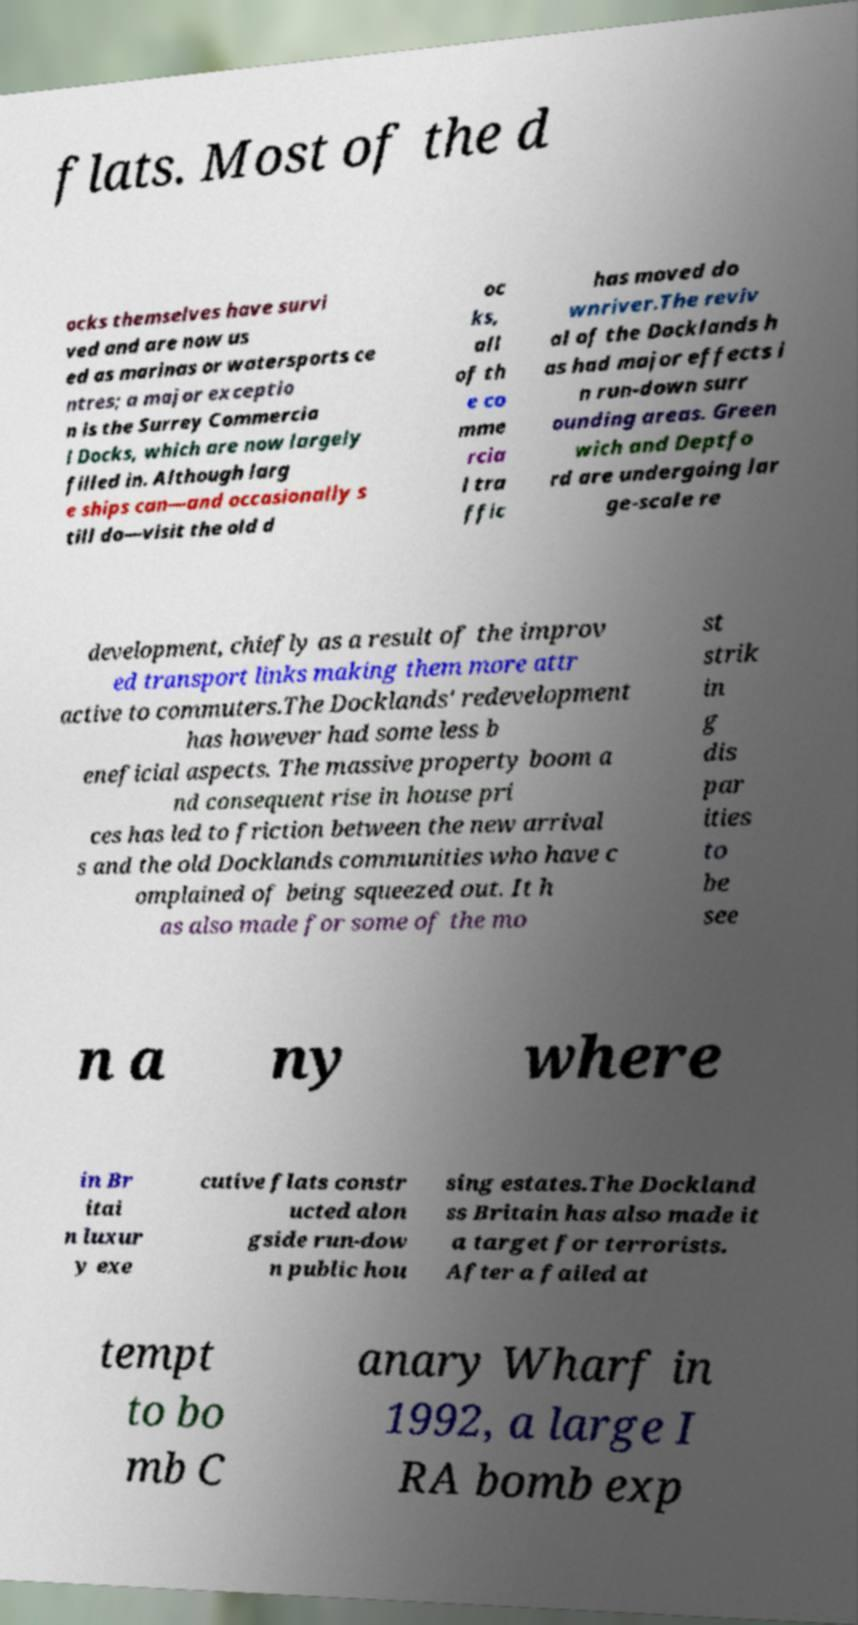For documentation purposes, I need the text within this image transcribed. Could you provide that? flats. Most of the d ocks themselves have survi ved and are now us ed as marinas or watersports ce ntres; a major exceptio n is the Surrey Commercia l Docks, which are now largely filled in. Although larg e ships can—and occasionally s till do—visit the old d oc ks, all of th e co mme rcia l tra ffic has moved do wnriver.The reviv al of the Docklands h as had major effects i n run-down surr ounding areas. Green wich and Deptfo rd are undergoing lar ge-scale re development, chiefly as a result of the improv ed transport links making them more attr active to commuters.The Docklands' redevelopment has however had some less b eneficial aspects. The massive property boom a nd consequent rise in house pri ces has led to friction between the new arrival s and the old Docklands communities who have c omplained of being squeezed out. It h as also made for some of the mo st strik in g dis par ities to be see n a ny where in Br itai n luxur y exe cutive flats constr ucted alon gside run-dow n public hou sing estates.The Dockland ss Britain has also made it a target for terrorists. After a failed at tempt to bo mb C anary Wharf in 1992, a large I RA bomb exp 